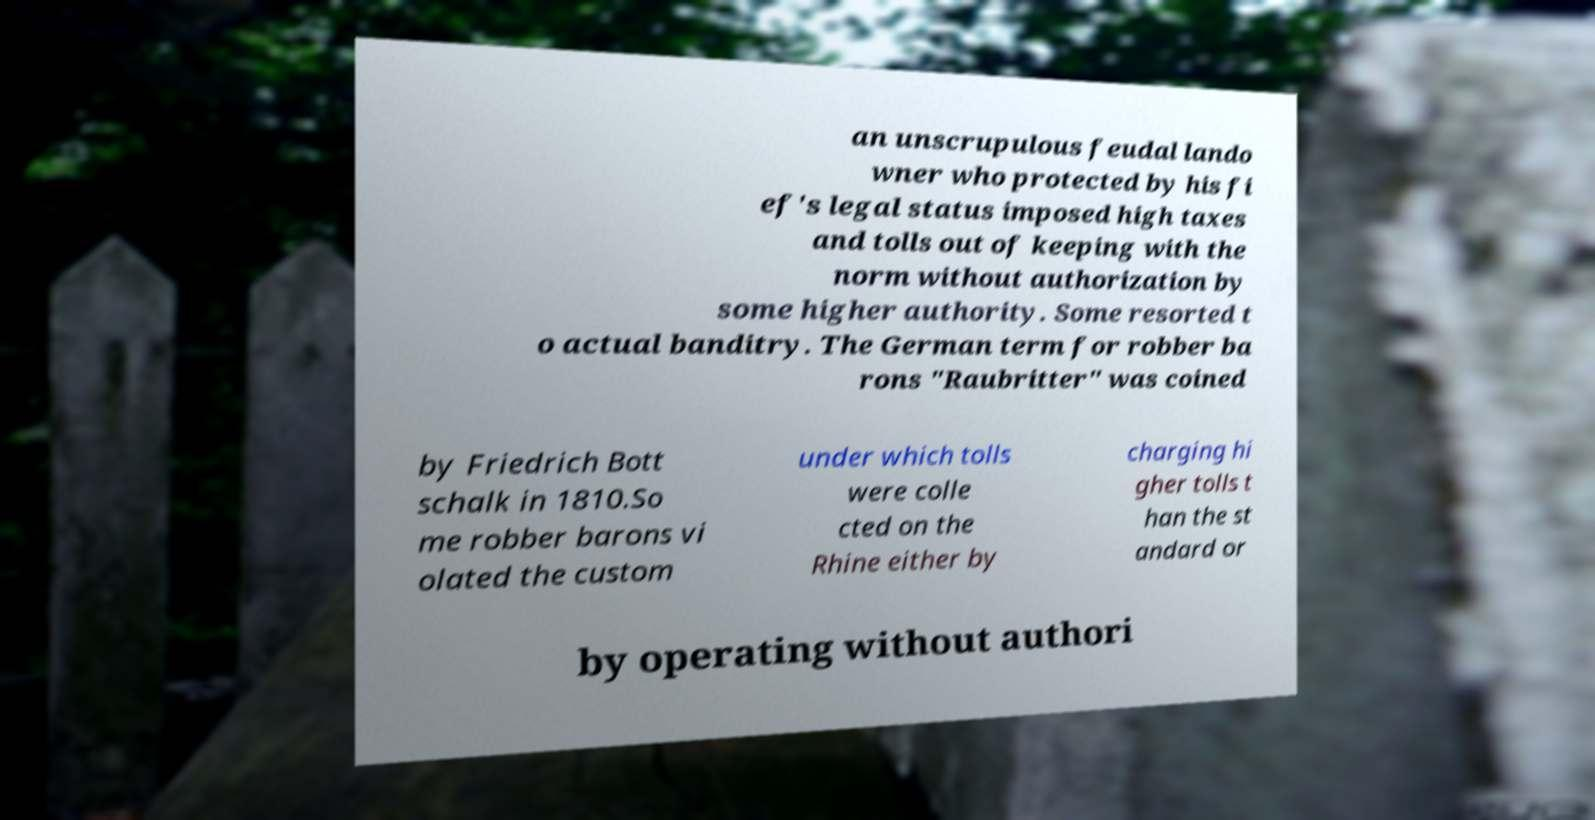Can you accurately transcribe the text from the provided image for me? an unscrupulous feudal lando wner who protected by his fi ef's legal status imposed high taxes and tolls out of keeping with the norm without authorization by some higher authority. Some resorted t o actual banditry. The German term for robber ba rons "Raubritter" was coined by Friedrich Bott schalk in 1810.So me robber barons vi olated the custom under which tolls were colle cted on the Rhine either by charging hi gher tolls t han the st andard or by operating without authori 